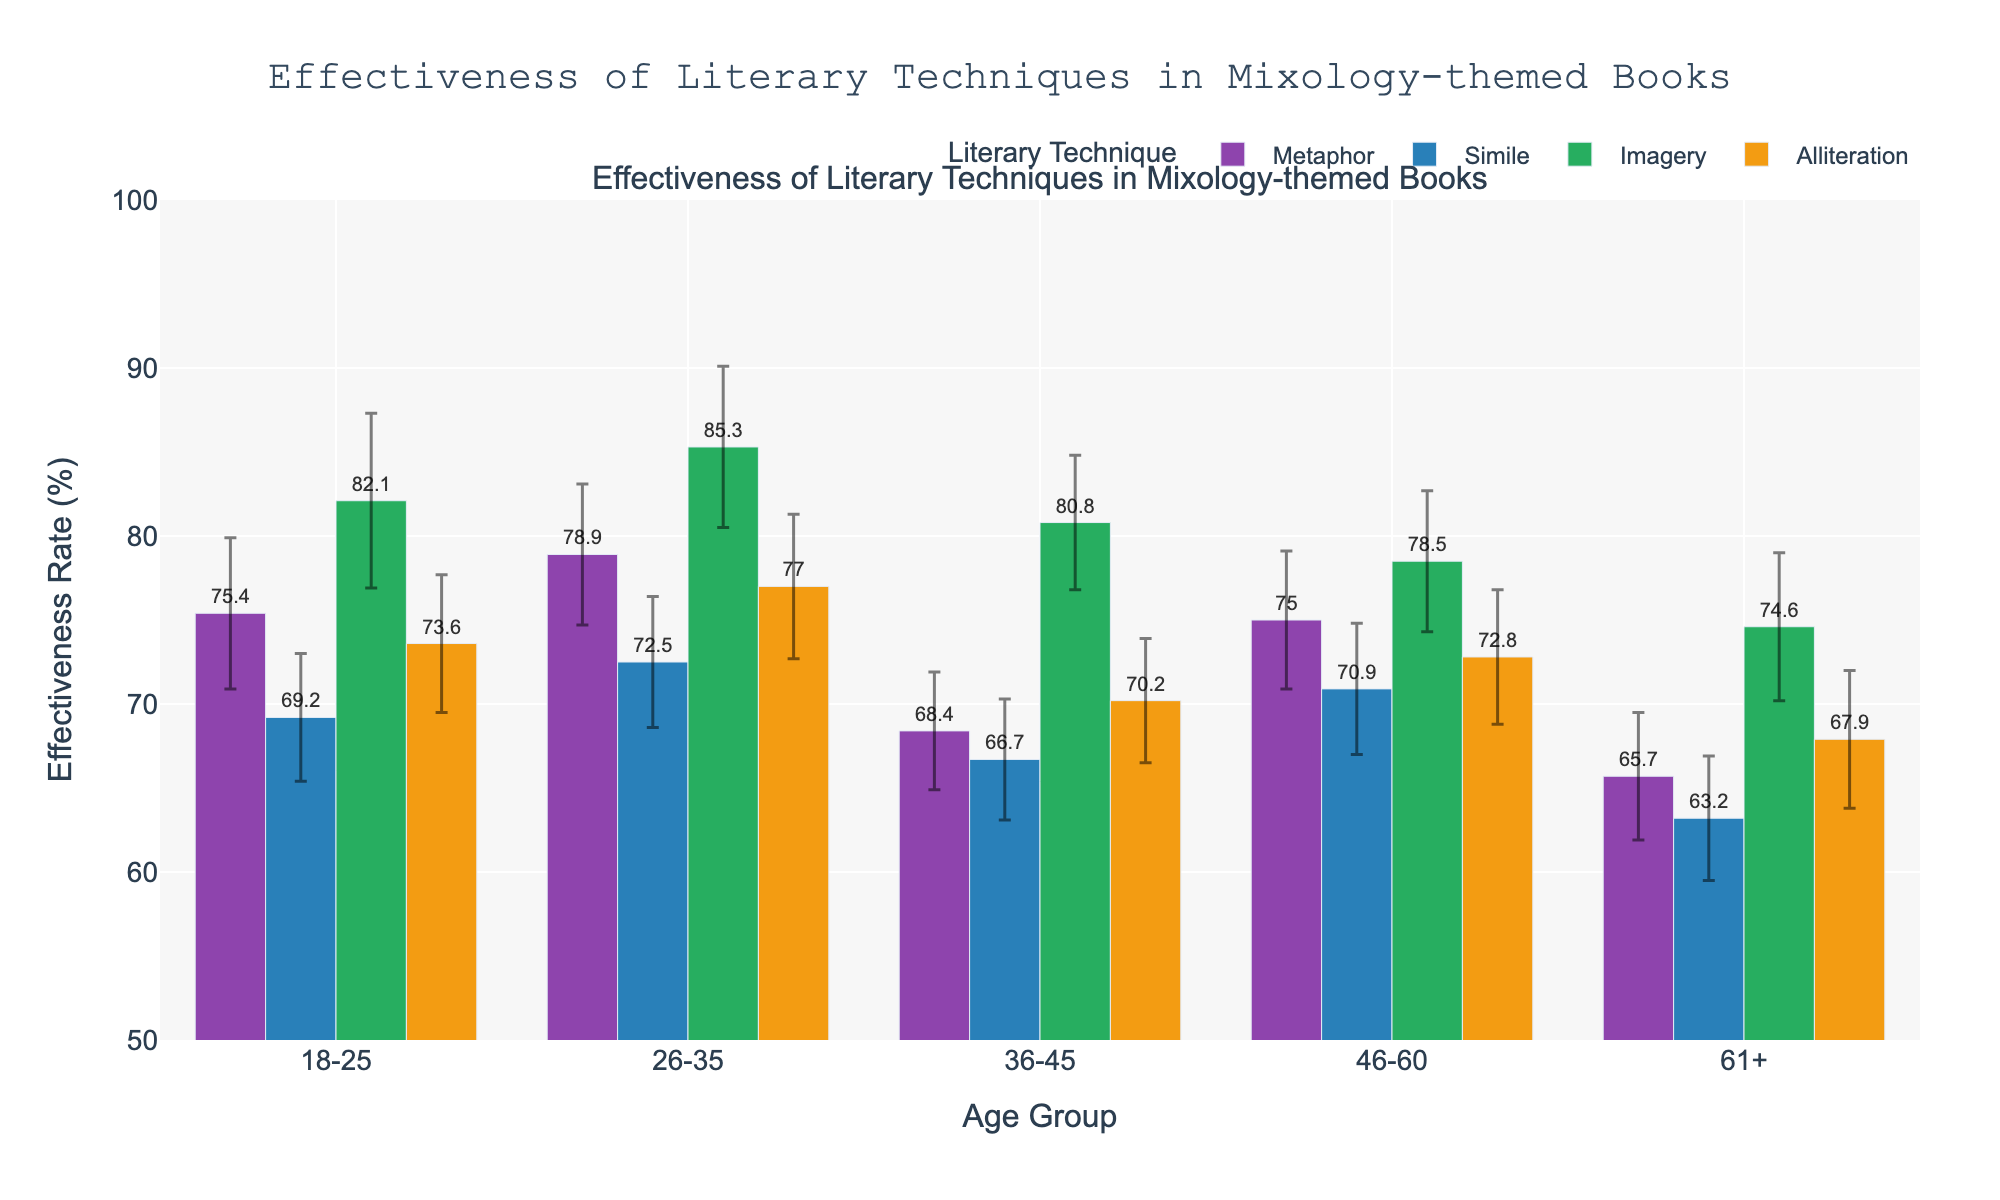What is the title of the figure? The title is presented at the top-centre of the figure in a prominent font. It describes the main subject of the plot, which is the effectiveness of literary techniques in mixology-themed books.
Answer: Effectiveness of Literary Techniques in Mixology-themed Books Which literary technique shows the highest effectiveness rate for the 18-25 age group? To find this, look at the bars corresponding to the 18-25 age group and compare their heights. The tallest bar represents the technique with the highest effectiveness rate.
Answer: Imagery What is the effectiveness rate of Metaphor for the 61+ age group? Locate the bar corresponding to the Metaphor technique within the 61+ age group. Read the number at the top of the bar or the y-axis value it aligns with.
Answer: 65.7% How does the effectiveness rate of Simile for the 26-35 age group compare to that of Imagery for the same age group? Compare the heights of the bars. Find the bar for Simile and the bar for Imagery within the 26-35 age group and note their effectiveness rates.
Answer: Simile is lower than Imagery What is the average effectiveness rate of Alliteration across all age groups? Find the effectiveness rates for Alliteration in each age group, sum them up, and divide by the number of age groups. Calculations: (73.6 + 77.0 + 70.2 + 72.8 + 67.9) / 5 = 72.3
Answer: 72.3% Which age group has the smallest margin of error for Simile? Look at the error bars (thin lines with a horizontal bar at each end) for Simile in each age group and find the smallest one.
Answer: 61+ How much higher is the effectiveness rate of Imagery compared to Metaphor in the 36-45 age group? Subtract the effectiveness rate of Metaphor from that of Imagery within the 36-45 age group. Calculation: 80.8 - 68.4 = 12.4
Answer: 12.4% What is the range of effectiveness rates for Metaphor across different age groups? Identify the highest and lowest effectiveness rates for Metaphor among all age groups and subtract the lower from the higher. Calculation: 78.9 - 65.7 = 13.2
Answer: 13.2 Do any age groups show an effectiveness rate of Imagery below 75%? Check the heights of the bars representing Imagery across all age groups and see if any are below 75%.
Answer: Yes Which literary technique has the most consistent effectiveness rate across all age groups? Look for the technique with the smallest spread (range) of effectiveness rates among all age groups.
Answer: Alliteration 